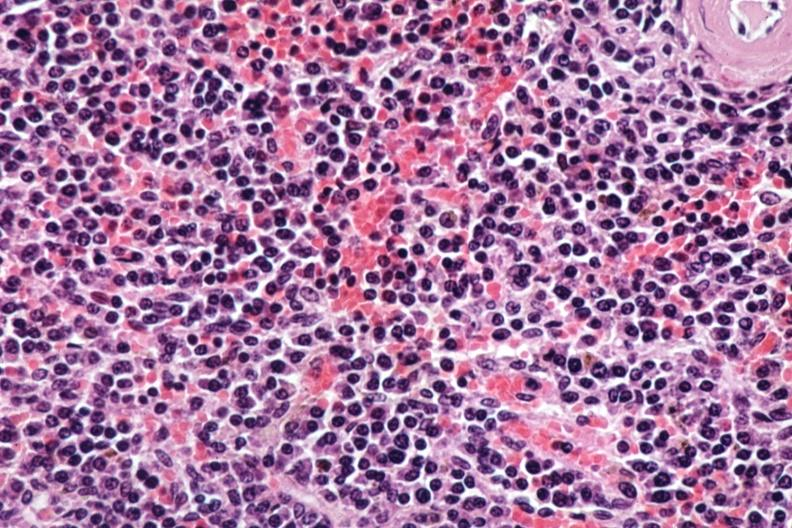s hematologic present?
Answer the question using a single word or phrase. Yes 